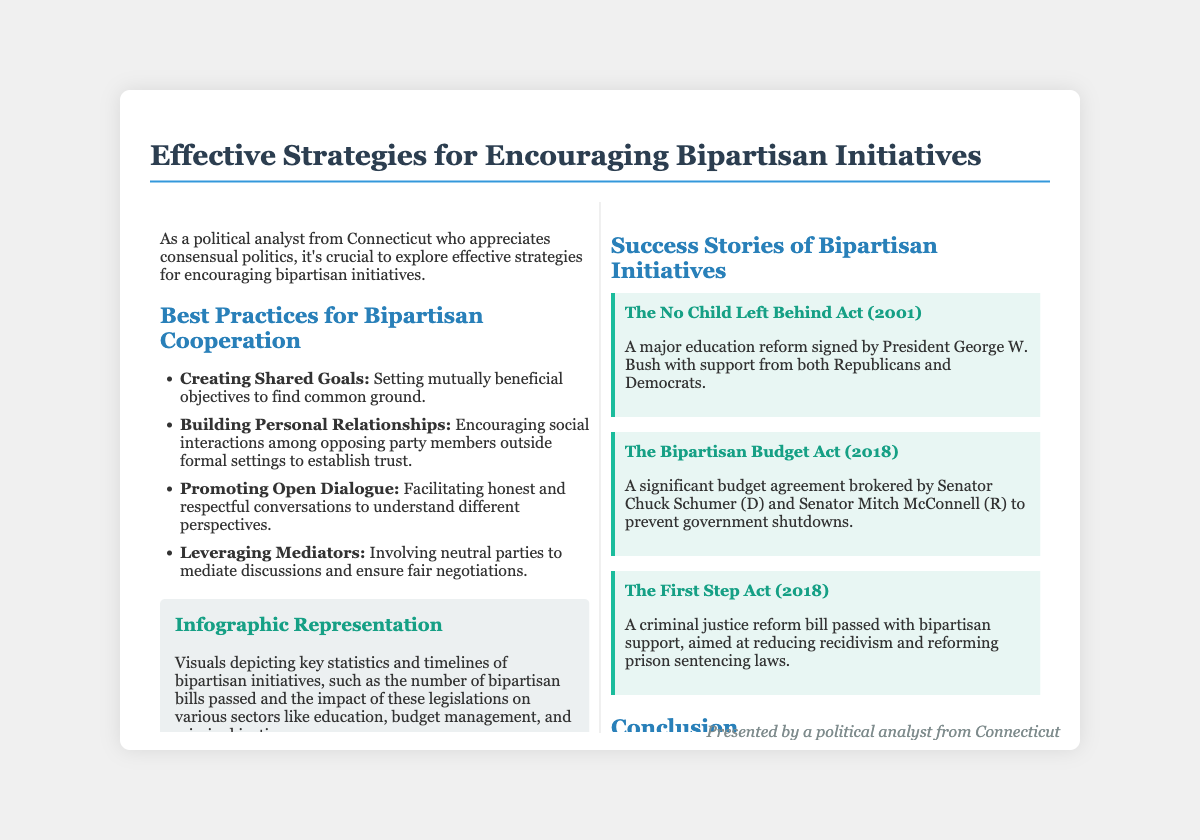What are the key practices for bipartisan cooperation? The document lists several best practices, including creating shared goals, building personal relationships, promoting open dialogue, and leveraging mediators.
Answer: Creating shared goals, building personal relationships, promoting open dialogue, leveraging mediators Which act was signed by President George W. Bush in 2001? The document refers to a major education reform signed in 2001 as The No Child Left Behind Act.
Answer: The No Child Left Behind Act Who brokered the Bipartisan Budget Act in 2018? According to the document, the Bipartisan Budget Act was brokered by Senator Chuck Schumer and Senator Mitch McConnell.
Answer: Senator Chuck Schumer and Senator Mitch McConnell What is emphasized as crucial for effective bipartisan initiatives? The document emphasizes dedication to shared goals, personal relationships, open dialogue, and mediators as crucial for effective initiatives.
Answer: Dedication to shared goals, personal relationships, open dialogue, mediators What does the infographic in the document depict? The infographic represents key statistics and timelines of bipartisan initiatives, including the number of bipartisan bills passed and their impact on various sectors.
Answer: Key statistics and timelines of bipartisan initiatives Which year was The First Step Act passed? The document states that The First Step Act was passed in 2018.
Answer: 2018 What role do mediators play in bipartisan cooperation? The document mentions that mediators are involved to ensure fair negotiations in bipartisan discussions.
Answer: Ensure fair negotiations What is the title of the presentation? The title of the presentation is "Effective Strategies for Encouraging Bipartisan Initiatives."
Answer: Effective Strategies for Encouraging Bipartisan Initiatives What type of story is provided for The First Step Act? The document describes The First Step Act as a success story of bipartisan support aimed at reducing recidivism and reforming laws.
Answer: Success story of bipartisan support aimed at reducing recidivism 